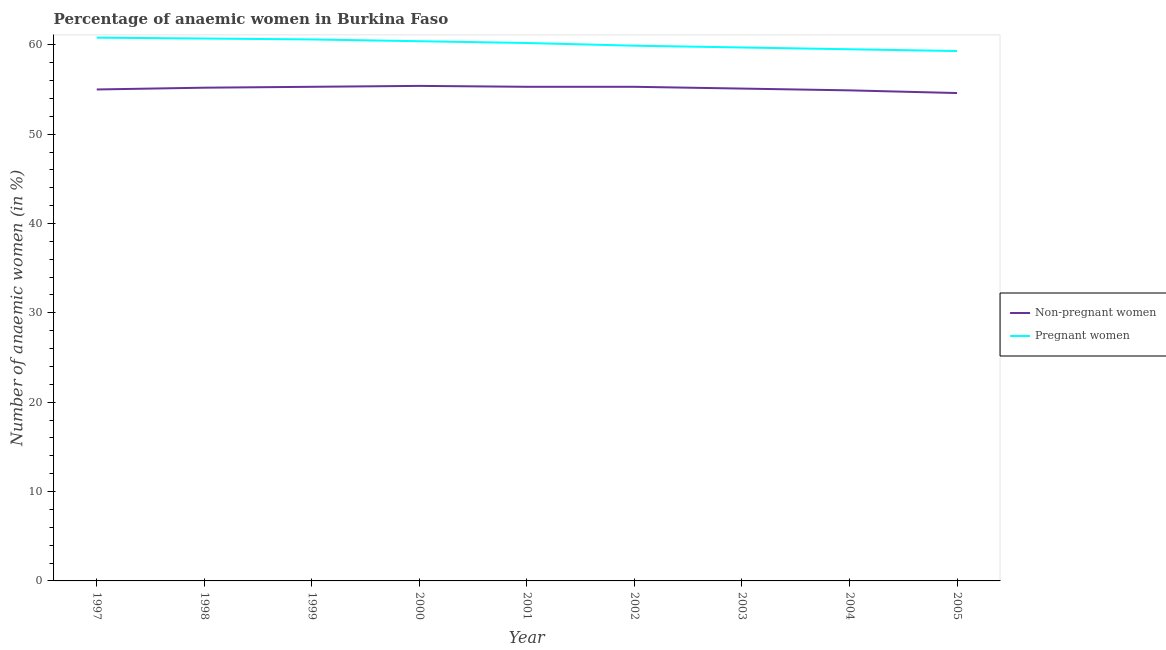How many different coloured lines are there?
Offer a very short reply. 2. Does the line corresponding to percentage of pregnant anaemic women intersect with the line corresponding to percentage of non-pregnant anaemic women?
Provide a short and direct response. No. Is the number of lines equal to the number of legend labels?
Provide a short and direct response. Yes. What is the percentage of non-pregnant anaemic women in 1997?
Provide a succinct answer. 55. Across all years, what is the maximum percentage of non-pregnant anaemic women?
Give a very brief answer. 55.4. Across all years, what is the minimum percentage of non-pregnant anaemic women?
Provide a succinct answer. 54.6. In which year was the percentage of pregnant anaemic women maximum?
Provide a succinct answer. 1997. What is the total percentage of pregnant anaemic women in the graph?
Provide a short and direct response. 541.1. What is the difference between the percentage of pregnant anaemic women in 1999 and that in 2000?
Ensure brevity in your answer.  0.2. What is the average percentage of non-pregnant anaemic women per year?
Ensure brevity in your answer.  55.12. In the year 2002, what is the difference between the percentage of non-pregnant anaemic women and percentage of pregnant anaemic women?
Your answer should be very brief. -4.6. What is the ratio of the percentage of non-pregnant anaemic women in 2002 to that in 2005?
Make the answer very short. 1.01. Is the difference between the percentage of non-pregnant anaemic women in 2001 and 2003 greater than the difference between the percentage of pregnant anaemic women in 2001 and 2003?
Ensure brevity in your answer.  No. What is the difference between the highest and the second highest percentage of pregnant anaemic women?
Provide a succinct answer. 0.1. What is the difference between the highest and the lowest percentage of non-pregnant anaemic women?
Make the answer very short. 0.8. In how many years, is the percentage of non-pregnant anaemic women greater than the average percentage of non-pregnant anaemic women taken over all years?
Your answer should be very brief. 5. Is the sum of the percentage of non-pregnant anaemic women in 2000 and 2004 greater than the maximum percentage of pregnant anaemic women across all years?
Offer a very short reply. Yes. How many lines are there?
Offer a very short reply. 2. Are the values on the major ticks of Y-axis written in scientific E-notation?
Ensure brevity in your answer.  No. Does the graph contain any zero values?
Your answer should be very brief. No. What is the title of the graph?
Your response must be concise. Percentage of anaemic women in Burkina Faso. Does "GDP at market prices" appear as one of the legend labels in the graph?
Provide a short and direct response. No. What is the label or title of the Y-axis?
Keep it short and to the point. Number of anaemic women (in %). What is the Number of anaemic women (in %) of Non-pregnant women in 1997?
Your response must be concise. 55. What is the Number of anaemic women (in %) in Pregnant women in 1997?
Make the answer very short. 60.8. What is the Number of anaemic women (in %) in Non-pregnant women in 1998?
Give a very brief answer. 55.2. What is the Number of anaemic women (in %) in Pregnant women in 1998?
Your response must be concise. 60.7. What is the Number of anaemic women (in %) of Non-pregnant women in 1999?
Provide a succinct answer. 55.3. What is the Number of anaemic women (in %) of Pregnant women in 1999?
Ensure brevity in your answer.  60.6. What is the Number of anaemic women (in %) in Non-pregnant women in 2000?
Your answer should be very brief. 55.4. What is the Number of anaemic women (in %) in Pregnant women in 2000?
Provide a succinct answer. 60.4. What is the Number of anaemic women (in %) of Non-pregnant women in 2001?
Ensure brevity in your answer.  55.3. What is the Number of anaemic women (in %) in Pregnant women in 2001?
Your response must be concise. 60.2. What is the Number of anaemic women (in %) of Non-pregnant women in 2002?
Offer a very short reply. 55.3. What is the Number of anaemic women (in %) of Pregnant women in 2002?
Ensure brevity in your answer.  59.9. What is the Number of anaemic women (in %) of Non-pregnant women in 2003?
Make the answer very short. 55.1. What is the Number of anaemic women (in %) of Pregnant women in 2003?
Your answer should be very brief. 59.7. What is the Number of anaemic women (in %) in Non-pregnant women in 2004?
Make the answer very short. 54.9. What is the Number of anaemic women (in %) of Pregnant women in 2004?
Your answer should be compact. 59.5. What is the Number of anaemic women (in %) of Non-pregnant women in 2005?
Give a very brief answer. 54.6. What is the Number of anaemic women (in %) of Pregnant women in 2005?
Make the answer very short. 59.3. Across all years, what is the maximum Number of anaemic women (in %) of Non-pregnant women?
Ensure brevity in your answer.  55.4. Across all years, what is the maximum Number of anaemic women (in %) of Pregnant women?
Your response must be concise. 60.8. Across all years, what is the minimum Number of anaemic women (in %) of Non-pregnant women?
Ensure brevity in your answer.  54.6. Across all years, what is the minimum Number of anaemic women (in %) of Pregnant women?
Offer a terse response. 59.3. What is the total Number of anaemic women (in %) in Non-pregnant women in the graph?
Provide a short and direct response. 496.1. What is the total Number of anaemic women (in %) in Pregnant women in the graph?
Keep it short and to the point. 541.1. What is the difference between the Number of anaemic women (in %) in Non-pregnant women in 1997 and that in 1998?
Provide a succinct answer. -0.2. What is the difference between the Number of anaemic women (in %) of Pregnant women in 1997 and that in 2000?
Offer a very short reply. 0.4. What is the difference between the Number of anaemic women (in %) of Pregnant women in 1997 and that in 2001?
Your answer should be compact. 0.6. What is the difference between the Number of anaemic women (in %) of Non-pregnant women in 1997 and that in 2002?
Offer a very short reply. -0.3. What is the difference between the Number of anaemic women (in %) in Non-pregnant women in 1997 and that in 2003?
Keep it short and to the point. -0.1. What is the difference between the Number of anaemic women (in %) in Pregnant women in 1997 and that in 2003?
Provide a succinct answer. 1.1. What is the difference between the Number of anaemic women (in %) in Pregnant women in 1998 and that in 1999?
Your response must be concise. 0.1. What is the difference between the Number of anaemic women (in %) in Non-pregnant women in 1998 and that in 2001?
Make the answer very short. -0.1. What is the difference between the Number of anaemic women (in %) of Non-pregnant women in 1998 and that in 2002?
Keep it short and to the point. -0.1. What is the difference between the Number of anaemic women (in %) in Pregnant women in 1998 and that in 2002?
Your response must be concise. 0.8. What is the difference between the Number of anaemic women (in %) of Non-pregnant women in 1998 and that in 2005?
Ensure brevity in your answer.  0.6. What is the difference between the Number of anaemic women (in %) of Pregnant women in 1998 and that in 2005?
Keep it short and to the point. 1.4. What is the difference between the Number of anaemic women (in %) in Pregnant women in 1999 and that in 2000?
Your response must be concise. 0.2. What is the difference between the Number of anaemic women (in %) of Pregnant women in 1999 and that in 2001?
Ensure brevity in your answer.  0.4. What is the difference between the Number of anaemic women (in %) in Non-pregnant women in 1999 and that in 2004?
Provide a succinct answer. 0.4. What is the difference between the Number of anaemic women (in %) of Pregnant women in 1999 and that in 2004?
Your response must be concise. 1.1. What is the difference between the Number of anaemic women (in %) in Non-pregnant women in 1999 and that in 2005?
Make the answer very short. 0.7. What is the difference between the Number of anaemic women (in %) in Pregnant women in 1999 and that in 2005?
Your answer should be compact. 1.3. What is the difference between the Number of anaemic women (in %) of Non-pregnant women in 2000 and that in 2001?
Make the answer very short. 0.1. What is the difference between the Number of anaemic women (in %) of Pregnant women in 2000 and that in 2001?
Keep it short and to the point. 0.2. What is the difference between the Number of anaemic women (in %) of Non-pregnant women in 2000 and that in 2002?
Provide a succinct answer. 0.1. What is the difference between the Number of anaemic women (in %) in Pregnant women in 2000 and that in 2003?
Offer a terse response. 0.7. What is the difference between the Number of anaemic women (in %) of Pregnant women in 2000 and that in 2005?
Ensure brevity in your answer.  1.1. What is the difference between the Number of anaemic women (in %) in Non-pregnant women in 2001 and that in 2002?
Make the answer very short. 0. What is the difference between the Number of anaemic women (in %) in Pregnant women in 2001 and that in 2002?
Your answer should be very brief. 0.3. What is the difference between the Number of anaemic women (in %) of Non-pregnant women in 2001 and that in 2003?
Keep it short and to the point. 0.2. What is the difference between the Number of anaemic women (in %) in Pregnant women in 2001 and that in 2003?
Offer a terse response. 0.5. What is the difference between the Number of anaemic women (in %) in Non-pregnant women in 2001 and that in 2004?
Offer a very short reply. 0.4. What is the difference between the Number of anaemic women (in %) of Pregnant women in 2001 and that in 2004?
Your answer should be compact. 0.7. What is the difference between the Number of anaemic women (in %) in Non-pregnant women in 2001 and that in 2005?
Provide a short and direct response. 0.7. What is the difference between the Number of anaemic women (in %) in Non-pregnant women in 2002 and that in 2005?
Provide a short and direct response. 0.7. What is the difference between the Number of anaemic women (in %) of Non-pregnant women in 2003 and that in 2004?
Offer a terse response. 0.2. What is the difference between the Number of anaemic women (in %) of Pregnant women in 2003 and that in 2004?
Give a very brief answer. 0.2. What is the difference between the Number of anaemic women (in %) in Non-pregnant women in 2003 and that in 2005?
Your answer should be compact. 0.5. What is the difference between the Number of anaemic women (in %) of Non-pregnant women in 2004 and that in 2005?
Your response must be concise. 0.3. What is the difference between the Number of anaemic women (in %) of Non-pregnant women in 1997 and the Number of anaemic women (in %) of Pregnant women in 1998?
Your answer should be very brief. -5.7. What is the difference between the Number of anaemic women (in %) in Non-pregnant women in 1997 and the Number of anaemic women (in %) in Pregnant women in 2000?
Offer a terse response. -5.4. What is the difference between the Number of anaemic women (in %) of Non-pregnant women in 1997 and the Number of anaemic women (in %) of Pregnant women in 2001?
Keep it short and to the point. -5.2. What is the difference between the Number of anaemic women (in %) in Non-pregnant women in 1997 and the Number of anaemic women (in %) in Pregnant women in 2004?
Provide a short and direct response. -4.5. What is the difference between the Number of anaemic women (in %) in Non-pregnant women in 1997 and the Number of anaemic women (in %) in Pregnant women in 2005?
Offer a terse response. -4.3. What is the difference between the Number of anaemic women (in %) in Non-pregnant women in 1998 and the Number of anaemic women (in %) in Pregnant women in 1999?
Your answer should be compact. -5.4. What is the difference between the Number of anaemic women (in %) in Non-pregnant women in 1998 and the Number of anaemic women (in %) in Pregnant women in 2001?
Provide a short and direct response. -5. What is the difference between the Number of anaemic women (in %) in Non-pregnant women in 1998 and the Number of anaemic women (in %) in Pregnant women in 2002?
Ensure brevity in your answer.  -4.7. What is the difference between the Number of anaemic women (in %) of Non-pregnant women in 1998 and the Number of anaemic women (in %) of Pregnant women in 2003?
Ensure brevity in your answer.  -4.5. What is the difference between the Number of anaemic women (in %) of Non-pregnant women in 1999 and the Number of anaemic women (in %) of Pregnant women in 2002?
Provide a succinct answer. -4.6. What is the difference between the Number of anaemic women (in %) in Non-pregnant women in 1999 and the Number of anaemic women (in %) in Pregnant women in 2003?
Your response must be concise. -4.4. What is the difference between the Number of anaemic women (in %) in Non-pregnant women in 1999 and the Number of anaemic women (in %) in Pregnant women in 2004?
Make the answer very short. -4.2. What is the difference between the Number of anaemic women (in %) of Non-pregnant women in 2000 and the Number of anaemic women (in %) of Pregnant women in 2001?
Keep it short and to the point. -4.8. What is the difference between the Number of anaemic women (in %) in Non-pregnant women in 2000 and the Number of anaemic women (in %) in Pregnant women in 2002?
Make the answer very short. -4.5. What is the difference between the Number of anaemic women (in %) in Non-pregnant women in 2000 and the Number of anaemic women (in %) in Pregnant women in 2005?
Offer a very short reply. -3.9. What is the difference between the Number of anaemic women (in %) of Non-pregnant women in 2001 and the Number of anaemic women (in %) of Pregnant women in 2002?
Offer a terse response. -4.6. What is the difference between the Number of anaemic women (in %) in Non-pregnant women in 2001 and the Number of anaemic women (in %) in Pregnant women in 2003?
Give a very brief answer. -4.4. What is the difference between the Number of anaemic women (in %) of Non-pregnant women in 2001 and the Number of anaemic women (in %) of Pregnant women in 2005?
Ensure brevity in your answer.  -4. What is the difference between the Number of anaemic women (in %) of Non-pregnant women in 2002 and the Number of anaemic women (in %) of Pregnant women in 2004?
Give a very brief answer. -4.2. What is the difference between the Number of anaemic women (in %) of Non-pregnant women in 2002 and the Number of anaemic women (in %) of Pregnant women in 2005?
Your response must be concise. -4. What is the difference between the Number of anaemic women (in %) of Non-pregnant women in 2003 and the Number of anaemic women (in %) of Pregnant women in 2004?
Keep it short and to the point. -4.4. What is the average Number of anaemic women (in %) in Non-pregnant women per year?
Your response must be concise. 55.12. What is the average Number of anaemic women (in %) of Pregnant women per year?
Provide a succinct answer. 60.12. In the year 1997, what is the difference between the Number of anaemic women (in %) in Non-pregnant women and Number of anaemic women (in %) in Pregnant women?
Your answer should be very brief. -5.8. In the year 1999, what is the difference between the Number of anaemic women (in %) in Non-pregnant women and Number of anaemic women (in %) in Pregnant women?
Give a very brief answer. -5.3. In the year 2000, what is the difference between the Number of anaemic women (in %) in Non-pregnant women and Number of anaemic women (in %) in Pregnant women?
Offer a terse response. -5. In the year 2001, what is the difference between the Number of anaemic women (in %) in Non-pregnant women and Number of anaemic women (in %) in Pregnant women?
Keep it short and to the point. -4.9. In the year 2002, what is the difference between the Number of anaemic women (in %) of Non-pregnant women and Number of anaemic women (in %) of Pregnant women?
Keep it short and to the point. -4.6. In the year 2003, what is the difference between the Number of anaemic women (in %) in Non-pregnant women and Number of anaemic women (in %) in Pregnant women?
Offer a terse response. -4.6. What is the ratio of the Number of anaemic women (in %) of Non-pregnant women in 1997 to that in 1998?
Give a very brief answer. 1. What is the ratio of the Number of anaemic women (in %) of Non-pregnant women in 1997 to that in 2000?
Offer a very short reply. 0.99. What is the ratio of the Number of anaemic women (in %) of Pregnant women in 1997 to that in 2000?
Your response must be concise. 1.01. What is the ratio of the Number of anaemic women (in %) of Non-pregnant women in 1997 to that in 2001?
Make the answer very short. 0.99. What is the ratio of the Number of anaemic women (in %) of Non-pregnant women in 1997 to that in 2002?
Give a very brief answer. 0.99. What is the ratio of the Number of anaemic women (in %) of Pregnant women in 1997 to that in 2003?
Your answer should be very brief. 1.02. What is the ratio of the Number of anaemic women (in %) of Pregnant women in 1997 to that in 2004?
Ensure brevity in your answer.  1.02. What is the ratio of the Number of anaemic women (in %) of Non-pregnant women in 1997 to that in 2005?
Offer a very short reply. 1.01. What is the ratio of the Number of anaemic women (in %) of Pregnant women in 1997 to that in 2005?
Keep it short and to the point. 1.03. What is the ratio of the Number of anaemic women (in %) of Pregnant women in 1998 to that in 1999?
Your answer should be compact. 1. What is the ratio of the Number of anaemic women (in %) in Non-pregnant women in 1998 to that in 2000?
Ensure brevity in your answer.  1. What is the ratio of the Number of anaemic women (in %) of Pregnant women in 1998 to that in 2001?
Your answer should be compact. 1.01. What is the ratio of the Number of anaemic women (in %) of Non-pregnant women in 1998 to that in 2002?
Ensure brevity in your answer.  1. What is the ratio of the Number of anaemic women (in %) of Pregnant women in 1998 to that in 2002?
Give a very brief answer. 1.01. What is the ratio of the Number of anaemic women (in %) in Non-pregnant women in 1998 to that in 2003?
Make the answer very short. 1. What is the ratio of the Number of anaemic women (in %) in Pregnant women in 1998 to that in 2003?
Offer a terse response. 1.02. What is the ratio of the Number of anaemic women (in %) of Non-pregnant women in 1998 to that in 2004?
Keep it short and to the point. 1.01. What is the ratio of the Number of anaemic women (in %) of Pregnant women in 1998 to that in 2004?
Provide a succinct answer. 1.02. What is the ratio of the Number of anaemic women (in %) of Pregnant women in 1998 to that in 2005?
Offer a very short reply. 1.02. What is the ratio of the Number of anaemic women (in %) in Non-pregnant women in 1999 to that in 2000?
Ensure brevity in your answer.  1. What is the ratio of the Number of anaemic women (in %) of Non-pregnant women in 1999 to that in 2001?
Give a very brief answer. 1. What is the ratio of the Number of anaemic women (in %) in Pregnant women in 1999 to that in 2001?
Your answer should be very brief. 1.01. What is the ratio of the Number of anaemic women (in %) in Non-pregnant women in 1999 to that in 2002?
Give a very brief answer. 1. What is the ratio of the Number of anaemic women (in %) of Pregnant women in 1999 to that in 2002?
Provide a succinct answer. 1.01. What is the ratio of the Number of anaemic women (in %) in Pregnant women in 1999 to that in 2003?
Offer a terse response. 1.02. What is the ratio of the Number of anaemic women (in %) in Non-pregnant women in 1999 to that in 2004?
Your answer should be very brief. 1.01. What is the ratio of the Number of anaemic women (in %) of Pregnant women in 1999 to that in 2004?
Provide a succinct answer. 1.02. What is the ratio of the Number of anaemic women (in %) in Non-pregnant women in 1999 to that in 2005?
Keep it short and to the point. 1.01. What is the ratio of the Number of anaemic women (in %) of Pregnant women in 1999 to that in 2005?
Keep it short and to the point. 1.02. What is the ratio of the Number of anaemic women (in %) of Non-pregnant women in 2000 to that in 2001?
Offer a very short reply. 1. What is the ratio of the Number of anaemic women (in %) in Pregnant women in 2000 to that in 2001?
Your answer should be compact. 1. What is the ratio of the Number of anaemic women (in %) of Non-pregnant women in 2000 to that in 2002?
Offer a terse response. 1. What is the ratio of the Number of anaemic women (in %) of Pregnant women in 2000 to that in 2002?
Provide a succinct answer. 1.01. What is the ratio of the Number of anaemic women (in %) in Non-pregnant women in 2000 to that in 2003?
Ensure brevity in your answer.  1.01. What is the ratio of the Number of anaemic women (in %) in Pregnant women in 2000 to that in 2003?
Your response must be concise. 1.01. What is the ratio of the Number of anaemic women (in %) in Non-pregnant women in 2000 to that in 2004?
Make the answer very short. 1.01. What is the ratio of the Number of anaemic women (in %) of Pregnant women in 2000 to that in 2004?
Offer a terse response. 1.02. What is the ratio of the Number of anaemic women (in %) of Non-pregnant women in 2000 to that in 2005?
Give a very brief answer. 1.01. What is the ratio of the Number of anaemic women (in %) of Pregnant women in 2000 to that in 2005?
Your answer should be very brief. 1.02. What is the ratio of the Number of anaemic women (in %) of Non-pregnant women in 2001 to that in 2003?
Offer a very short reply. 1. What is the ratio of the Number of anaemic women (in %) in Pregnant women in 2001 to that in 2003?
Ensure brevity in your answer.  1.01. What is the ratio of the Number of anaemic women (in %) of Non-pregnant women in 2001 to that in 2004?
Your response must be concise. 1.01. What is the ratio of the Number of anaemic women (in %) of Pregnant women in 2001 to that in 2004?
Your answer should be very brief. 1.01. What is the ratio of the Number of anaemic women (in %) in Non-pregnant women in 2001 to that in 2005?
Keep it short and to the point. 1.01. What is the ratio of the Number of anaemic women (in %) of Pregnant women in 2001 to that in 2005?
Offer a terse response. 1.02. What is the ratio of the Number of anaemic women (in %) of Non-pregnant women in 2002 to that in 2004?
Ensure brevity in your answer.  1.01. What is the ratio of the Number of anaemic women (in %) in Pregnant women in 2002 to that in 2004?
Provide a succinct answer. 1.01. What is the ratio of the Number of anaemic women (in %) in Non-pregnant women in 2002 to that in 2005?
Provide a short and direct response. 1.01. What is the ratio of the Number of anaemic women (in %) of Non-pregnant women in 2003 to that in 2004?
Keep it short and to the point. 1. What is the ratio of the Number of anaemic women (in %) of Non-pregnant women in 2003 to that in 2005?
Ensure brevity in your answer.  1.01. What is the ratio of the Number of anaemic women (in %) in Pregnant women in 2003 to that in 2005?
Offer a very short reply. 1.01. What is the ratio of the Number of anaemic women (in %) in Non-pregnant women in 2004 to that in 2005?
Make the answer very short. 1.01. 